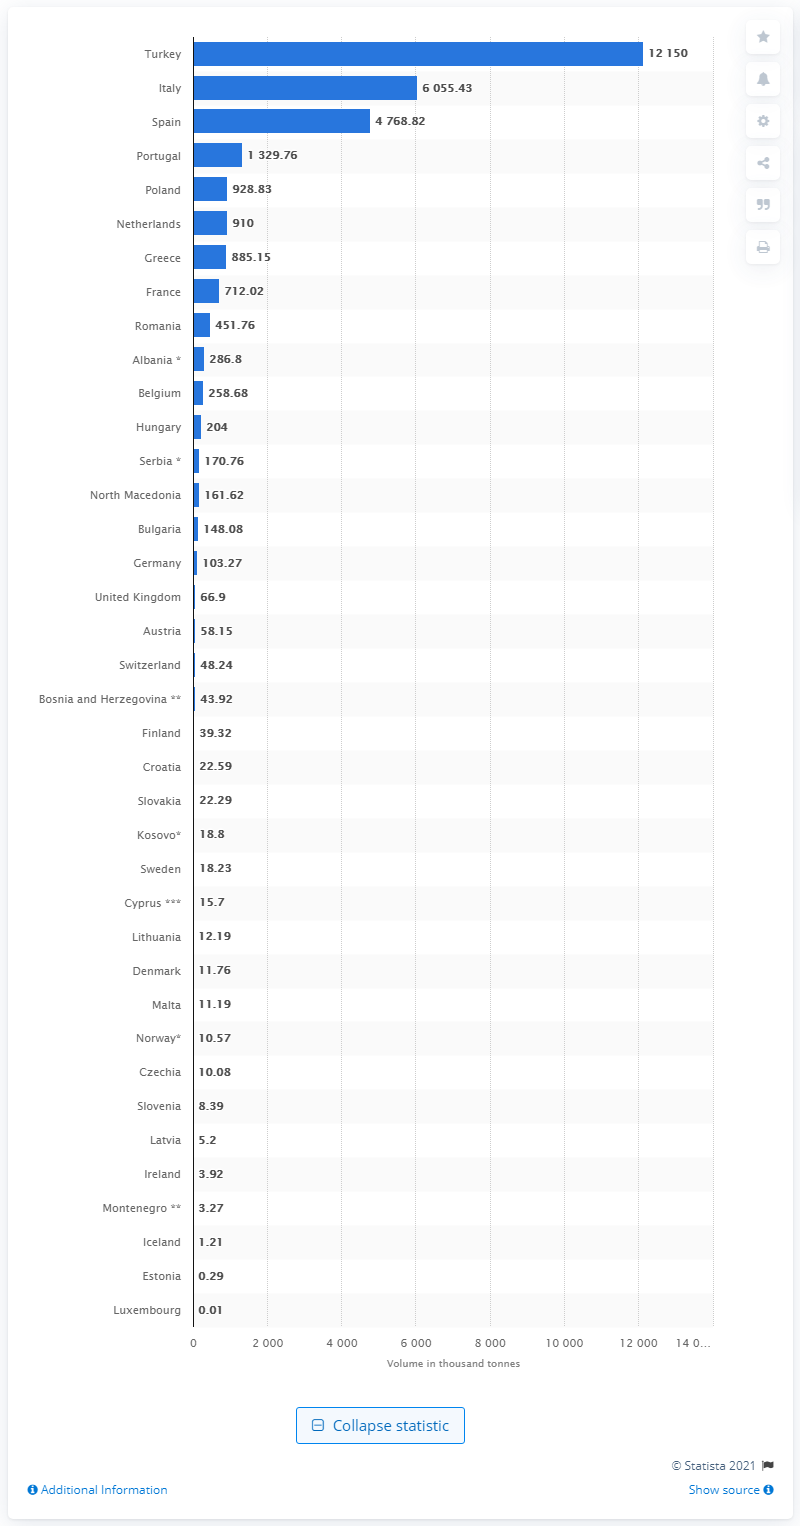Give some essential details in this illustration. In 2018, Turkey produced the greatest quantity of tomatoes. 